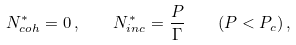Convert formula to latex. <formula><loc_0><loc_0><loc_500><loc_500>N _ { c o h } ^ { * } = 0 \, , \quad N _ { i n c } ^ { * } = \frac { P } { \Gamma } \quad ( P < P _ { c } ) \, ,</formula> 